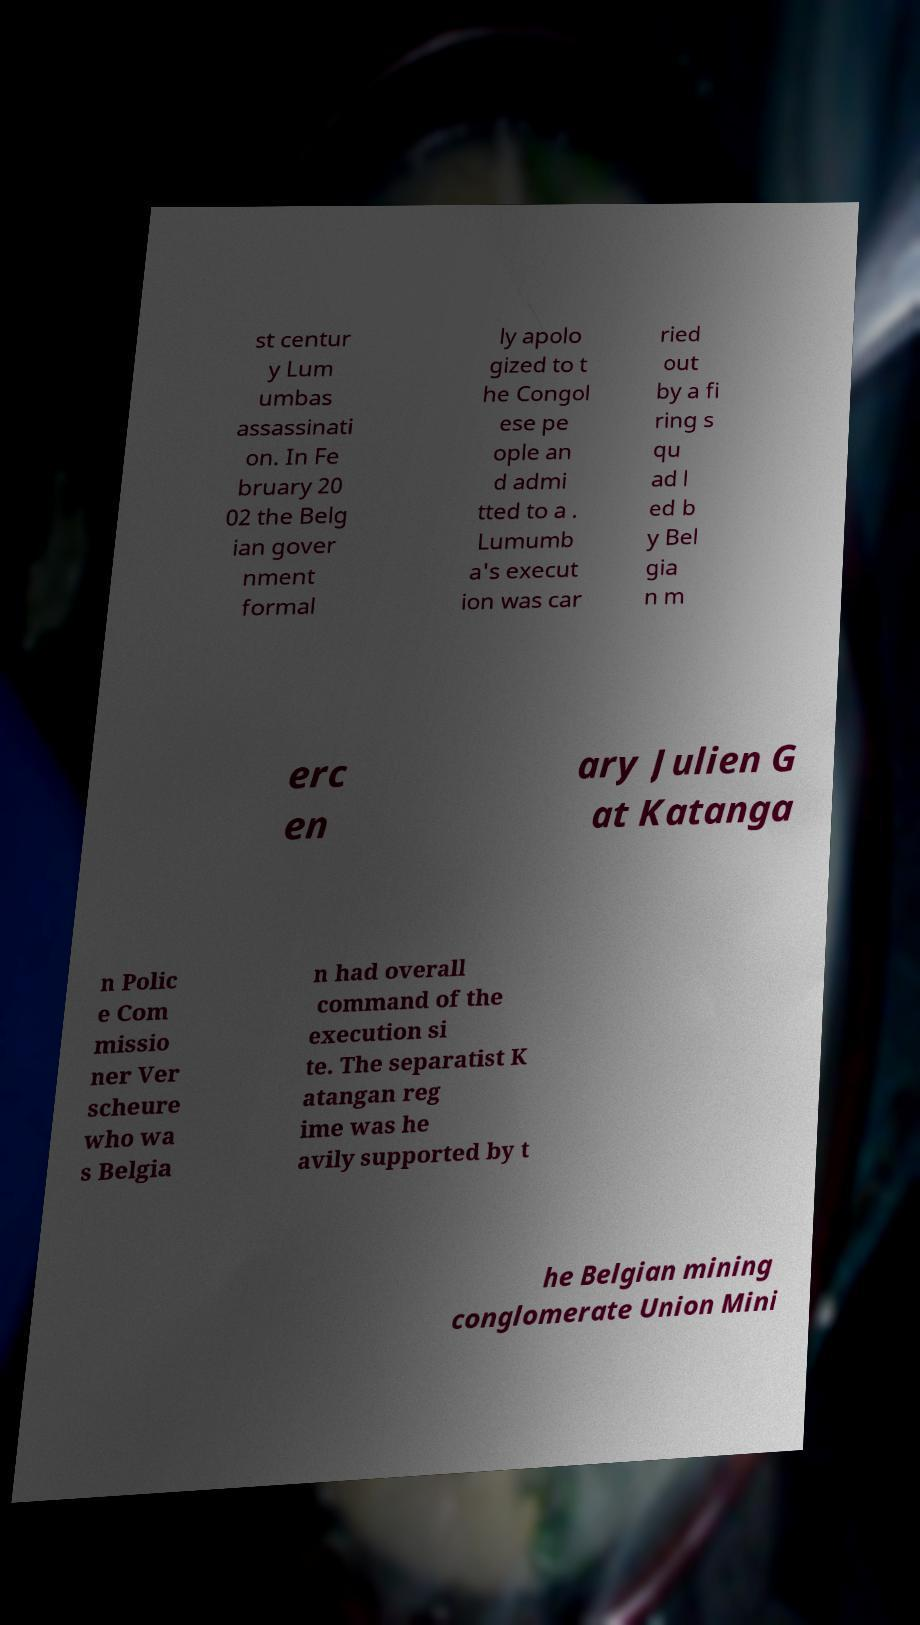Can you read and provide the text displayed in the image?This photo seems to have some interesting text. Can you extract and type it out for me? st centur y Lum umbas assassinati on. In Fe bruary 20 02 the Belg ian gover nment formal ly apolo gized to t he Congol ese pe ople an d admi tted to a . Lumumb a's execut ion was car ried out by a fi ring s qu ad l ed b y Bel gia n m erc en ary Julien G at Katanga n Polic e Com missio ner Ver scheure who wa s Belgia n had overall command of the execution si te. The separatist K atangan reg ime was he avily supported by t he Belgian mining conglomerate Union Mini 